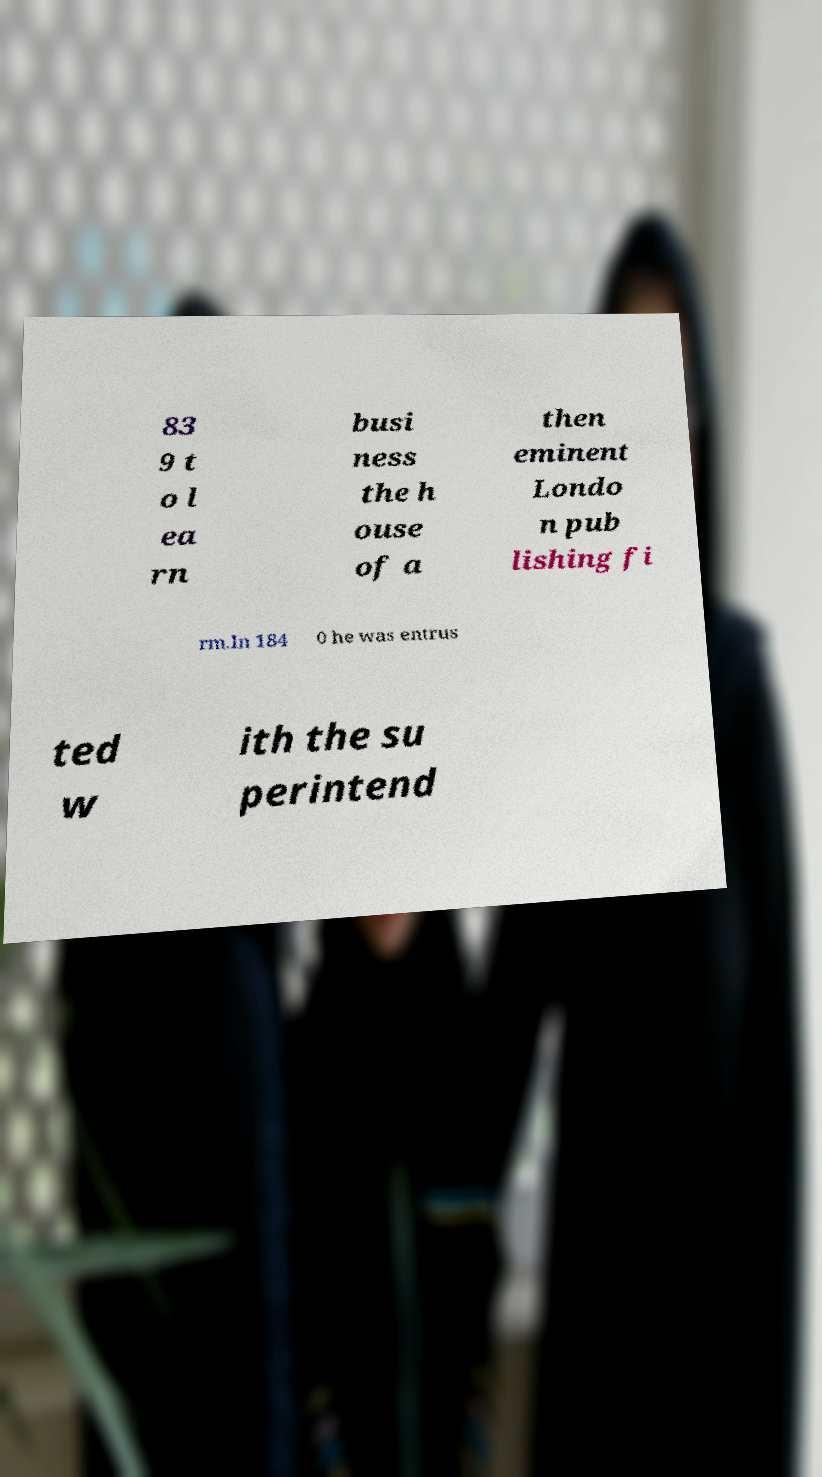There's text embedded in this image that I need extracted. Can you transcribe it verbatim? 83 9 t o l ea rn busi ness the h ouse of a then eminent Londo n pub lishing fi rm.In 184 0 he was entrus ted w ith the su perintend 